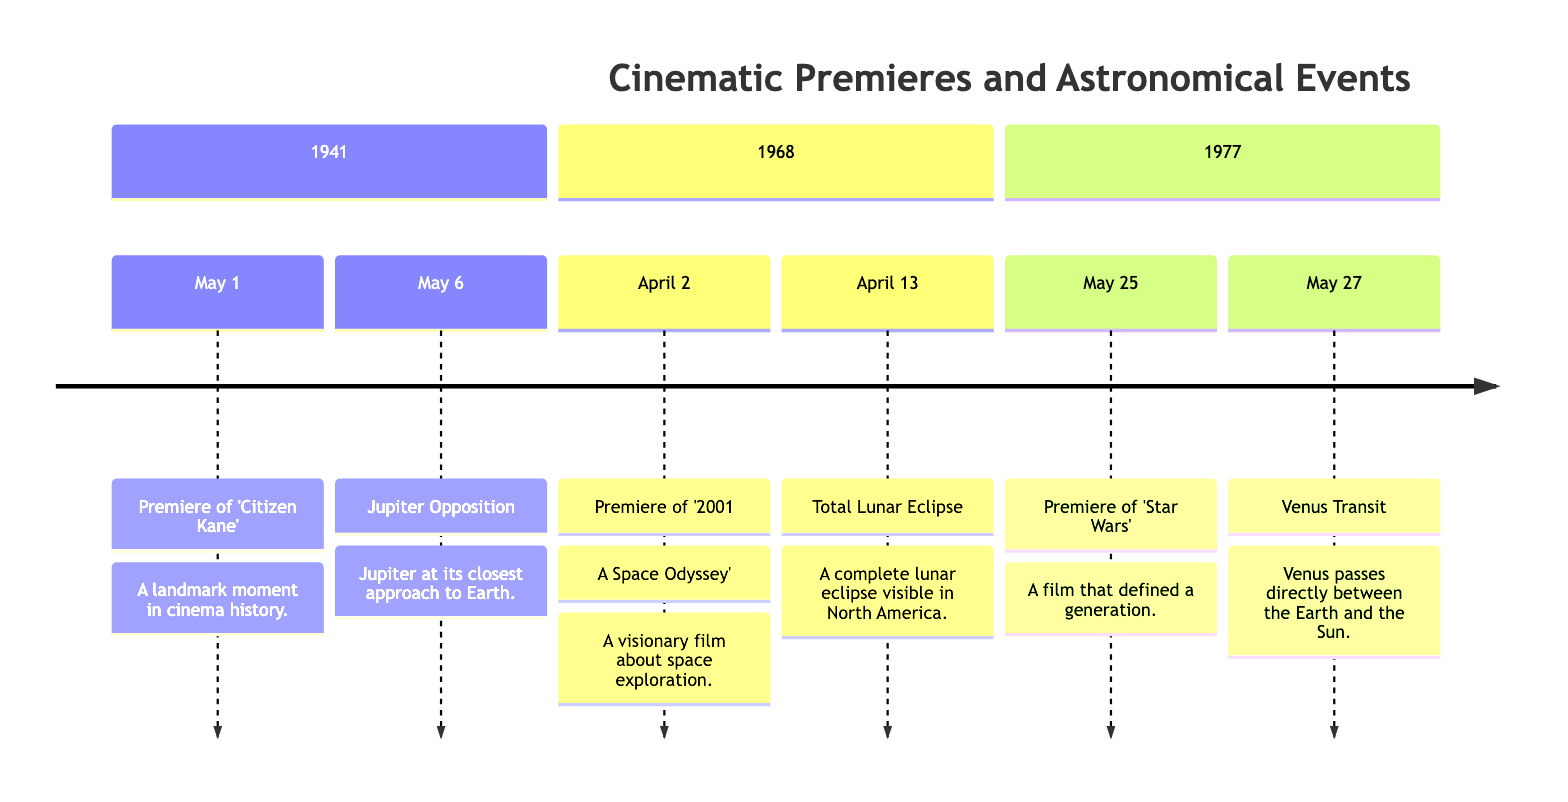What is the premiere date of 'Citizen Kane'? The diagram specifies 'Citizen Kane' premiered on May 1, 1941.
Answer: May 1, 1941 How many major events are listed for the year 1968? The diagram shows two events listed for 1968: the premiere of '2001: A Space Odyssey' and a total lunar eclipse.
Answer: 2 What astronomical event occurred on May 27, 1977? The diagram indicates that a Venus Transit occurred on May 27, 1977.
Answer: Venus Transit Which film had a premiere closest to Jupiter's opposition in 1941? By comparing the dates, 'Citizen Kane' premiered on May 1, and Jupiter's opposition was on May 6, making 'Citizen Kane' the film closest to the event.
Answer: Citizen Kane What is the month of the total lunar eclipse in 1968? The diagram shows that the total lunar eclipse took place in April 1968.
Answer: April How many films premiered in the same month as a notable astronomical event in 1977? The diagram illustrates that 'Star Wars' premiered in May 1977, coinciding with the Venus Transit on May 27. Thus, only one film premiered that month.
Answer: 1 Which event occurred right after the premiere of '2001: A Space Odyssey'? The total lunar eclipse occurred right after the premiere event, listed on April 13, 1968.
Answer: Total Lunar Eclipse What year features both a film premiere and an astronomical event on the same date? The year 1977 shows 'Star Wars' premiere on May 25 and Venus Transit shortly after, but no event on the same date. Therefore, there are no such occurrences in the diagram.
Answer: None 